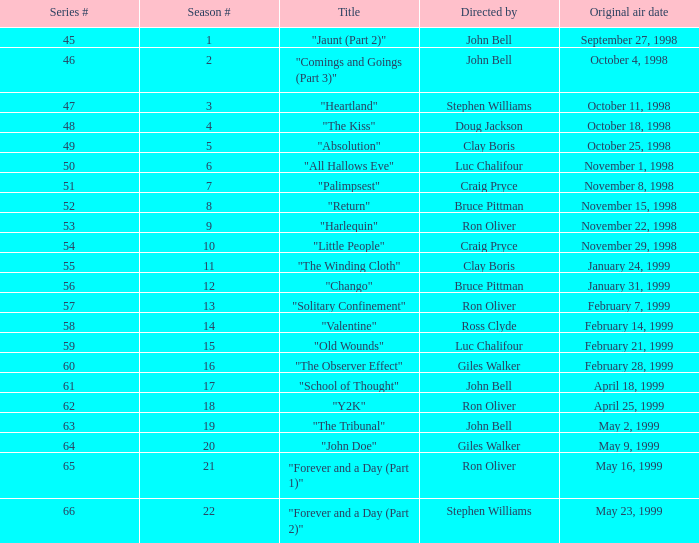Which Season # has a Title of "jaunt (part 2)", and a Series # larger than 45? None. 